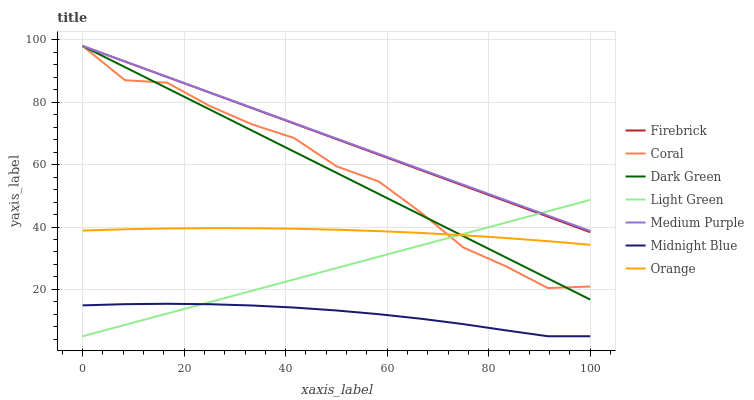Does Midnight Blue have the minimum area under the curve?
Answer yes or no. Yes. Does Medium Purple have the maximum area under the curve?
Answer yes or no. Yes. Does Firebrick have the minimum area under the curve?
Answer yes or no. No. Does Firebrick have the maximum area under the curve?
Answer yes or no. No. Is Light Green the smoothest?
Answer yes or no. Yes. Is Coral the roughest?
Answer yes or no. Yes. Is Firebrick the smoothest?
Answer yes or no. No. Is Firebrick the roughest?
Answer yes or no. No. Does Midnight Blue have the lowest value?
Answer yes or no. Yes. Does Firebrick have the lowest value?
Answer yes or no. No. Does Dark Green have the highest value?
Answer yes or no. Yes. Does Light Green have the highest value?
Answer yes or no. No. Is Orange less than Firebrick?
Answer yes or no. Yes. Is Medium Purple greater than Orange?
Answer yes or no. Yes. Does Light Green intersect Firebrick?
Answer yes or no. Yes. Is Light Green less than Firebrick?
Answer yes or no. No. Is Light Green greater than Firebrick?
Answer yes or no. No. Does Orange intersect Firebrick?
Answer yes or no. No. 